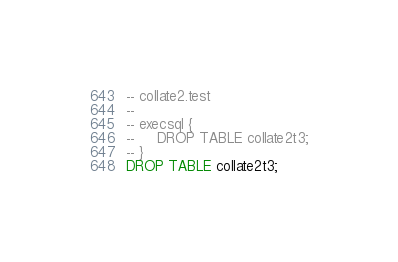<code> <loc_0><loc_0><loc_500><loc_500><_SQL_>-- collate2.test
-- 
-- execsql {
--     DROP TABLE collate2t3;
-- }
DROP TABLE collate2t3;</code> 